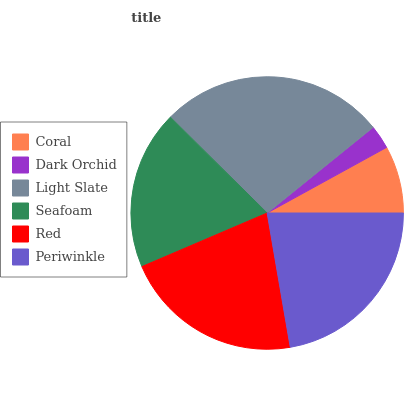Is Dark Orchid the minimum?
Answer yes or no. Yes. Is Light Slate the maximum?
Answer yes or no. Yes. Is Light Slate the minimum?
Answer yes or no. No. Is Dark Orchid the maximum?
Answer yes or no. No. Is Light Slate greater than Dark Orchid?
Answer yes or no. Yes. Is Dark Orchid less than Light Slate?
Answer yes or no. Yes. Is Dark Orchid greater than Light Slate?
Answer yes or no. No. Is Light Slate less than Dark Orchid?
Answer yes or no. No. Is Red the high median?
Answer yes or no. Yes. Is Seafoam the low median?
Answer yes or no. Yes. Is Dark Orchid the high median?
Answer yes or no. No. Is Periwinkle the low median?
Answer yes or no. No. 